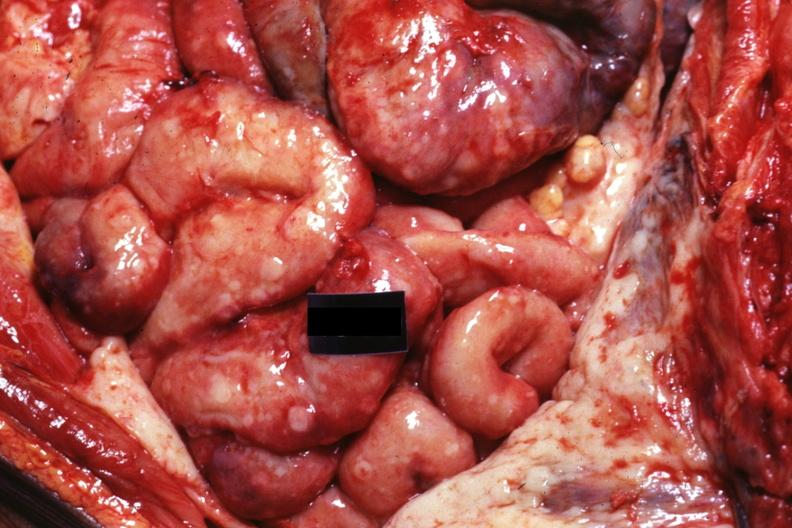s opened abdominal cavity with massive tumor in omentum none apparent in liver nor over peritoneal surfaces gut present?
Answer the question using a single word or phrase. No 